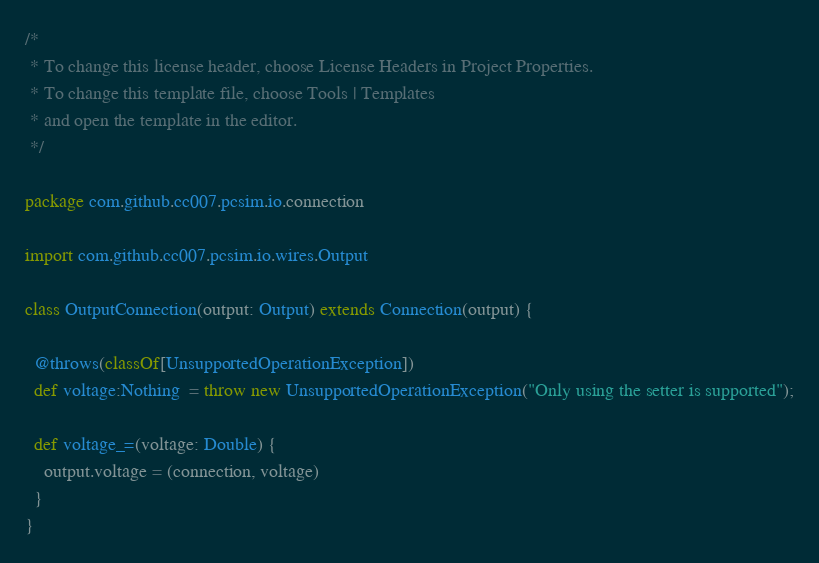<code> <loc_0><loc_0><loc_500><loc_500><_Scala_>/*
 * To change this license header, choose License Headers in Project Properties.
 * To change this template file, choose Tools | Templates
 * and open the template in the editor.
 */

package com.github.cc007.pcsim.io.connection

import com.github.cc007.pcsim.io.wires.Output

class OutputConnection(output: Output) extends Connection(output) {

  @throws(classOf[UnsupportedOperationException])
  def voltage:Nothing  = throw new UnsupportedOperationException("Only using the setter is supported");
  
  def voltage_=(voltage: Double) {
    output.voltage = (connection, voltage)
  }
}
</code> 